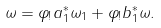<formula> <loc_0><loc_0><loc_500><loc_500>\omega = \varphi _ { ! } a _ { 1 } ^ { * } \omega _ { 1 } + \varphi _ { ! } b _ { 1 } ^ { * } \omega .</formula> 